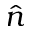Convert formula to latex. <formula><loc_0><loc_0><loc_500><loc_500>\hat { n }</formula> 